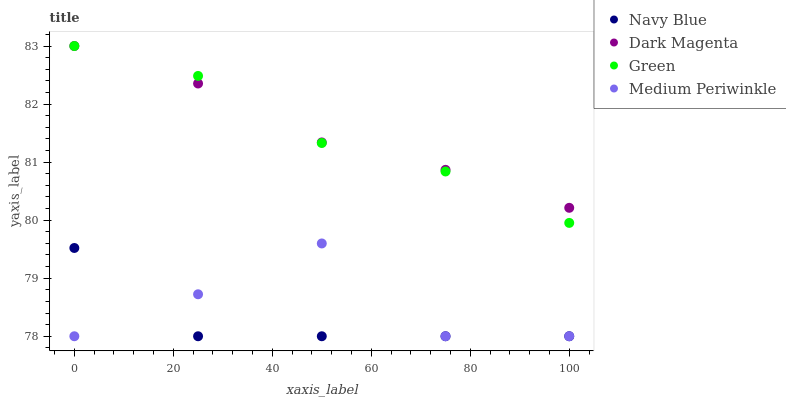Does Navy Blue have the minimum area under the curve?
Answer yes or no. Yes. Does Dark Magenta have the maximum area under the curve?
Answer yes or no. Yes. Does Green have the minimum area under the curve?
Answer yes or no. No. Does Green have the maximum area under the curve?
Answer yes or no. No. Is Dark Magenta the smoothest?
Answer yes or no. Yes. Is Medium Periwinkle the roughest?
Answer yes or no. Yes. Is Green the smoothest?
Answer yes or no. No. Is Green the roughest?
Answer yes or no. No. Does Navy Blue have the lowest value?
Answer yes or no. Yes. Does Green have the lowest value?
Answer yes or no. No. Does Dark Magenta have the highest value?
Answer yes or no. Yes. Does Medium Periwinkle have the highest value?
Answer yes or no. No. Is Medium Periwinkle less than Green?
Answer yes or no. Yes. Is Green greater than Medium Periwinkle?
Answer yes or no. Yes. Does Navy Blue intersect Medium Periwinkle?
Answer yes or no. Yes. Is Navy Blue less than Medium Periwinkle?
Answer yes or no. No. Is Navy Blue greater than Medium Periwinkle?
Answer yes or no. No. Does Medium Periwinkle intersect Green?
Answer yes or no. No. 